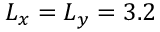<formula> <loc_0><loc_0><loc_500><loc_500>L _ { x } = L _ { y } = 3 . 2</formula> 